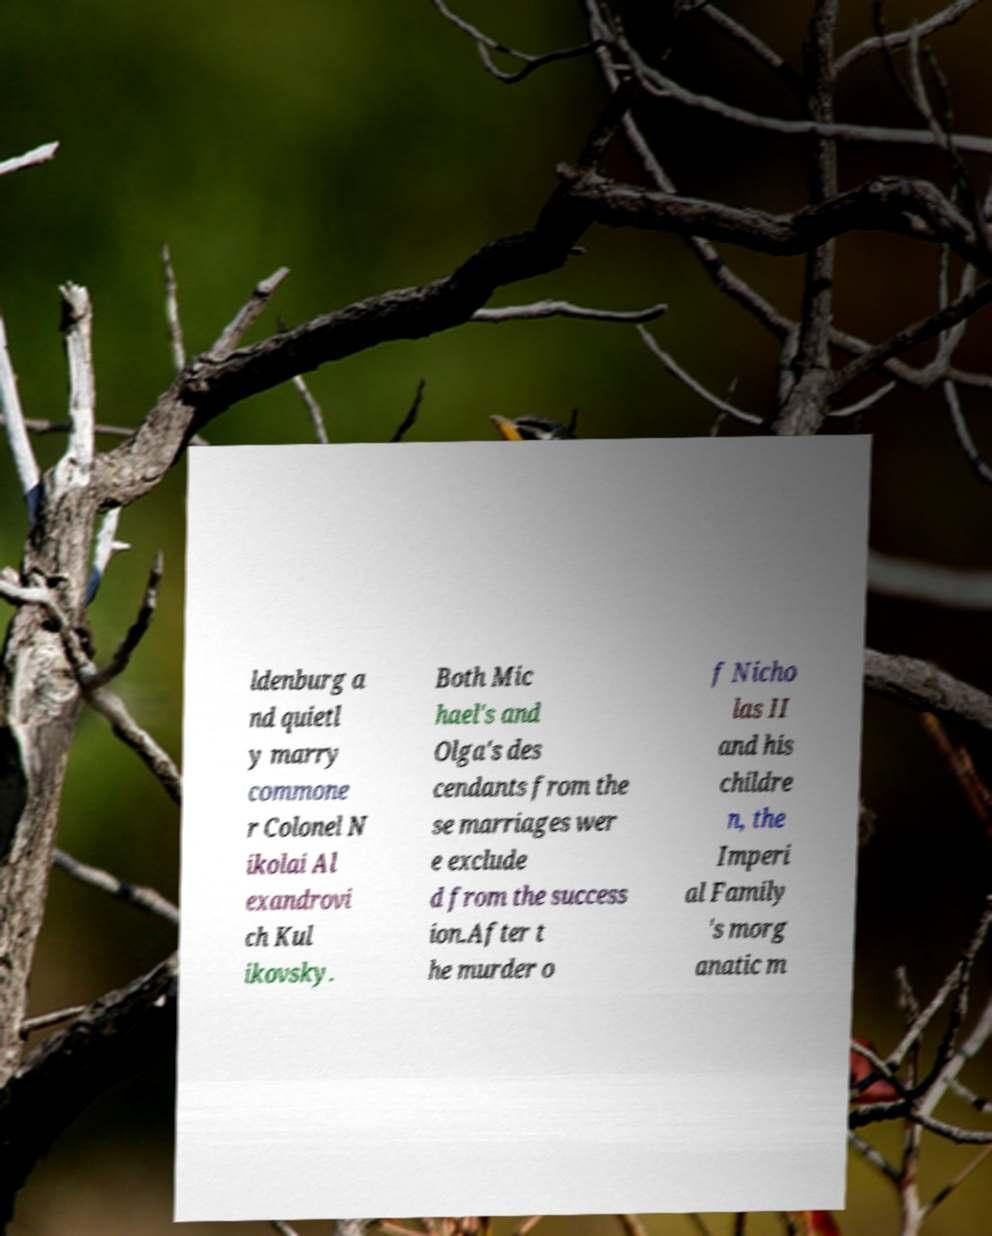Please read and relay the text visible in this image. What does it say? ldenburg a nd quietl y marry commone r Colonel N ikolai Al exandrovi ch Kul ikovsky. Both Mic hael's and Olga's des cendants from the se marriages wer e exclude d from the success ion.After t he murder o f Nicho las II and his childre n, the Imperi al Family 's morg anatic m 